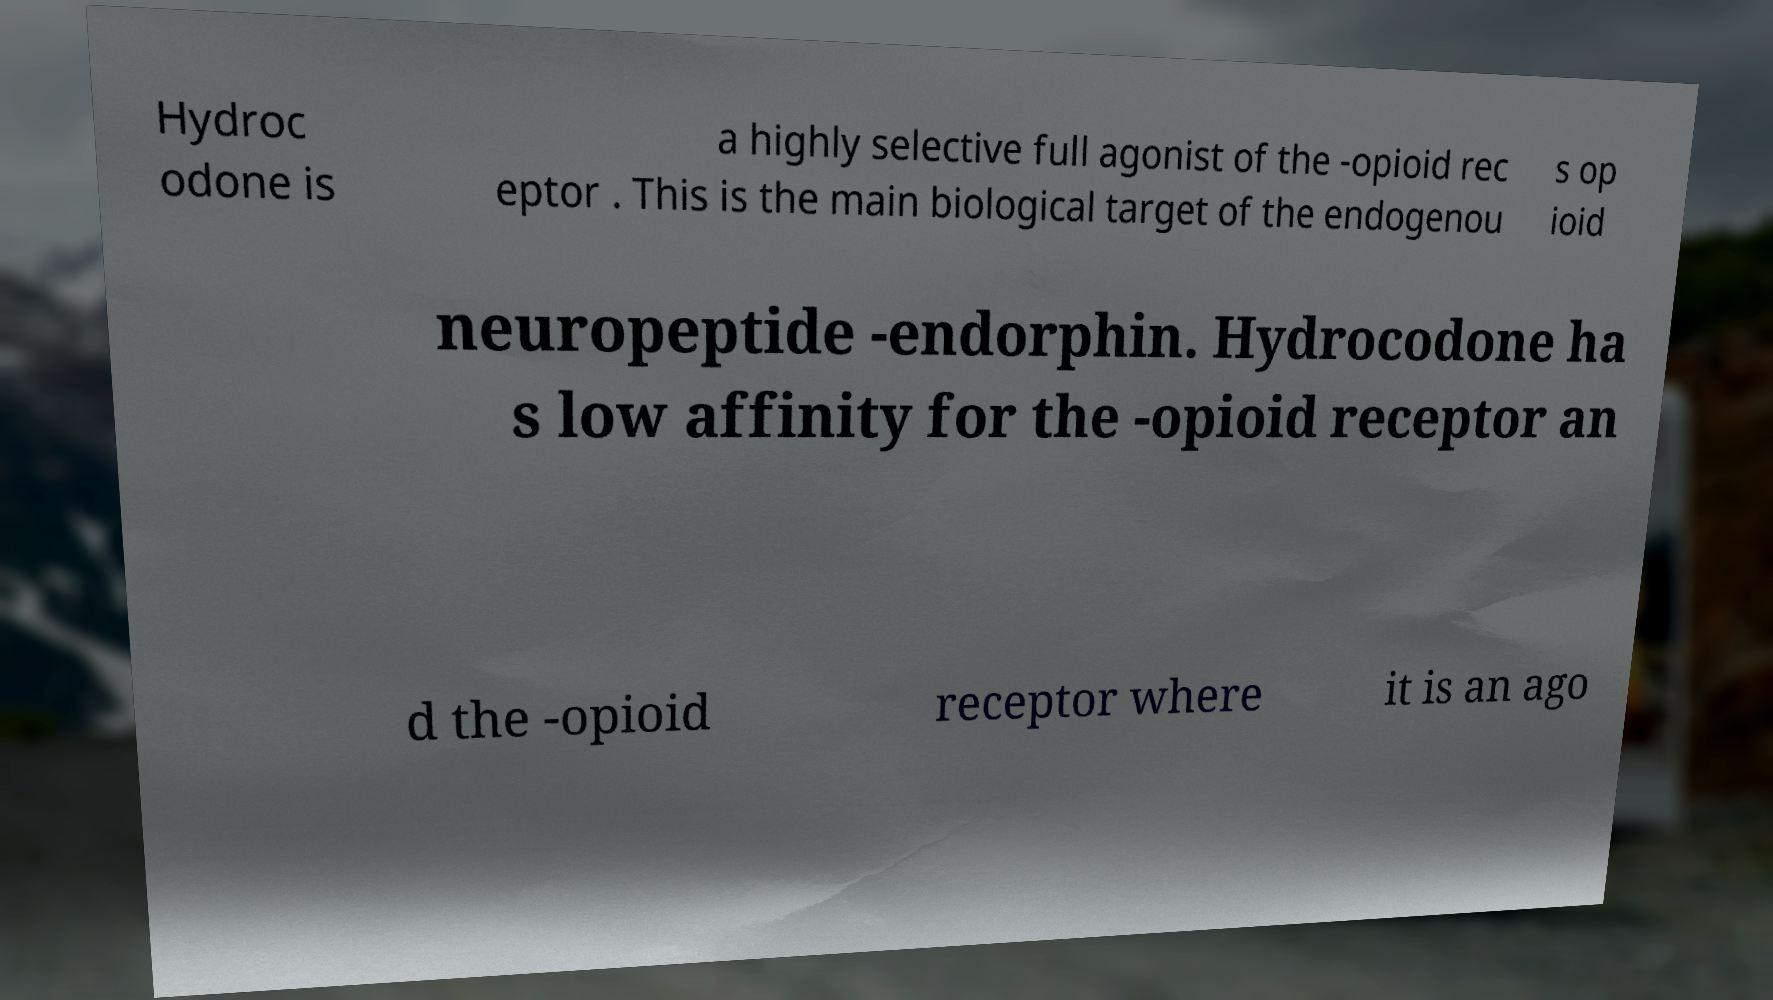Could you extract and type out the text from this image? Hydroc odone is a highly selective full agonist of the -opioid rec eptor . This is the main biological target of the endogenou s op ioid neuropeptide -endorphin. Hydrocodone ha s low affinity for the -opioid receptor an d the -opioid receptor where it is an ago 